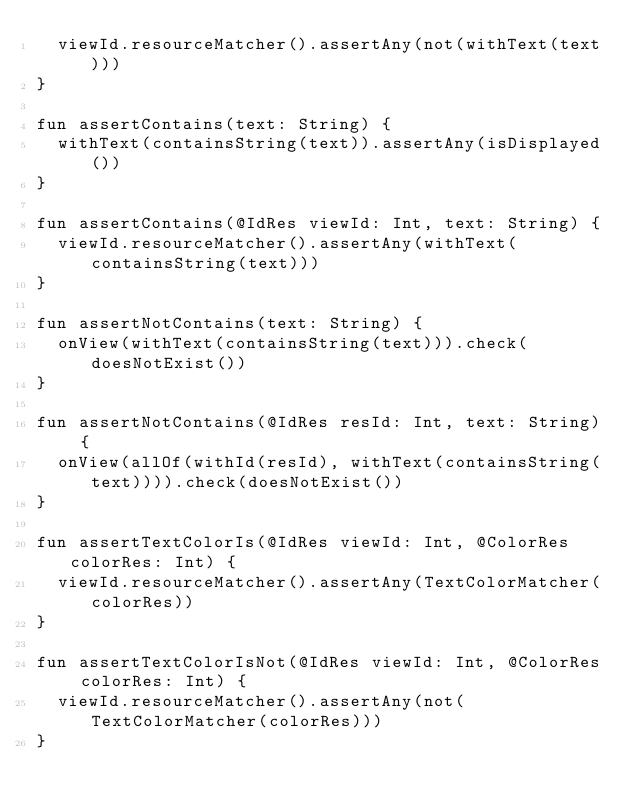<code> <loc_0><loc_0><loc_500><loc_500><_Kotlin_>  viewId.resourceMatcher().assertAny(not(withText(text)))
}

fun assertContains(text: String) {
  withText(containsString(text)).assertAny(isDisplayed())
}

fun assertContains(@IdRes viewId: Int, text: String) {
  viewId.resourceMatcher().assertAny(withText(containsString(text)))
}

fun assertNotContains(text: String) {
  onView(withText(containsString(text))).check(doesNotExist())
}

fun assertNotContains(@IdRes resId: Int, text: String) {
  onView(allOf(withId(resId), withText(containsString(text)))).check(doesNotExist())
}

fun assertTextColorIs(@IdRes viewId: Int, @ColorRes colorRes: Int) {
  viewId.resourceMatcher().assertAny(TextColorMatcher(colorRes))
}

fun assertTextColorIsNot(@IdRes viewId: Int, @ColorRes colorRes: Int) {
  viewId.resourceMatcher().assertAny(not(TextColorMatcher(colorRes)))
}
</code> 